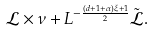Convert formula to latex. <formula><loc_0><loc_0><loc_500><loc_500>\mathcal { L } \times \nu + L ^ { - \frac { ( d + 1 + \alpha ) \xi + 1 } { 2 } } \tilde { \mathcal { L } } .</formula> 